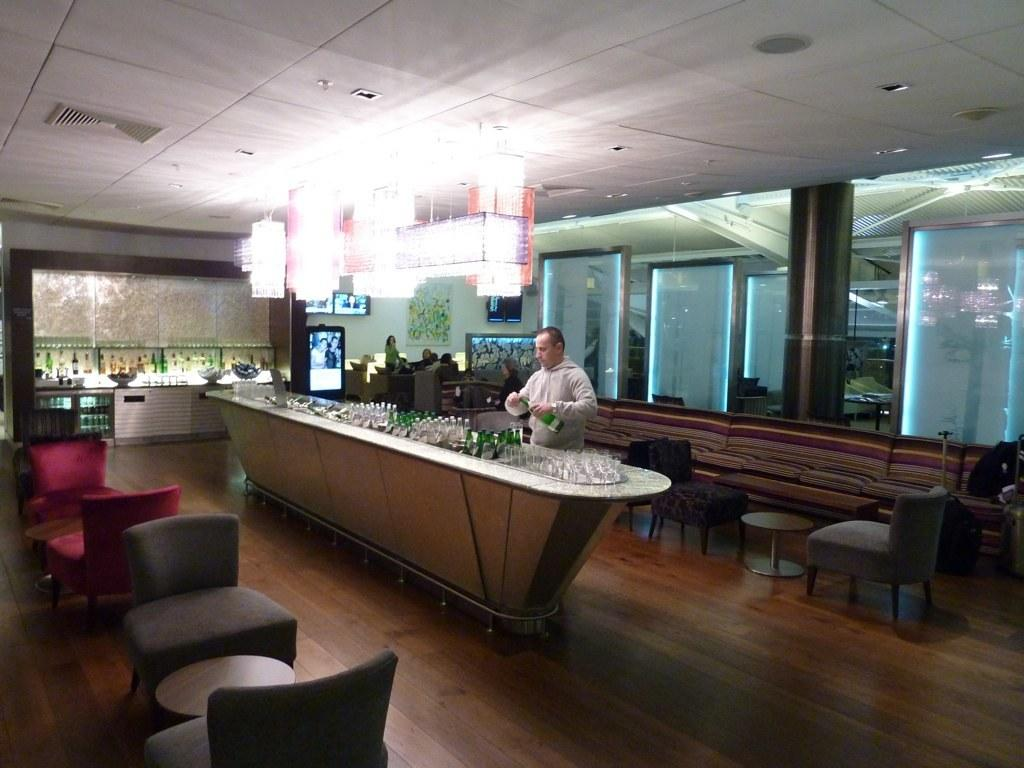What is the color of the wall in the image? The wall in the image is white. What piece of furniture can be seen in the image? There is a table in the image. Are there any seating options in the image? Yes, there are chairs in the image. Who is present in the image? There is a man standing in the image. What items are on the table in the image? There are bottles on the table in the image. What type of gold lace is draped over the man's shoulders in the image? There is no gold lace present in the image. 